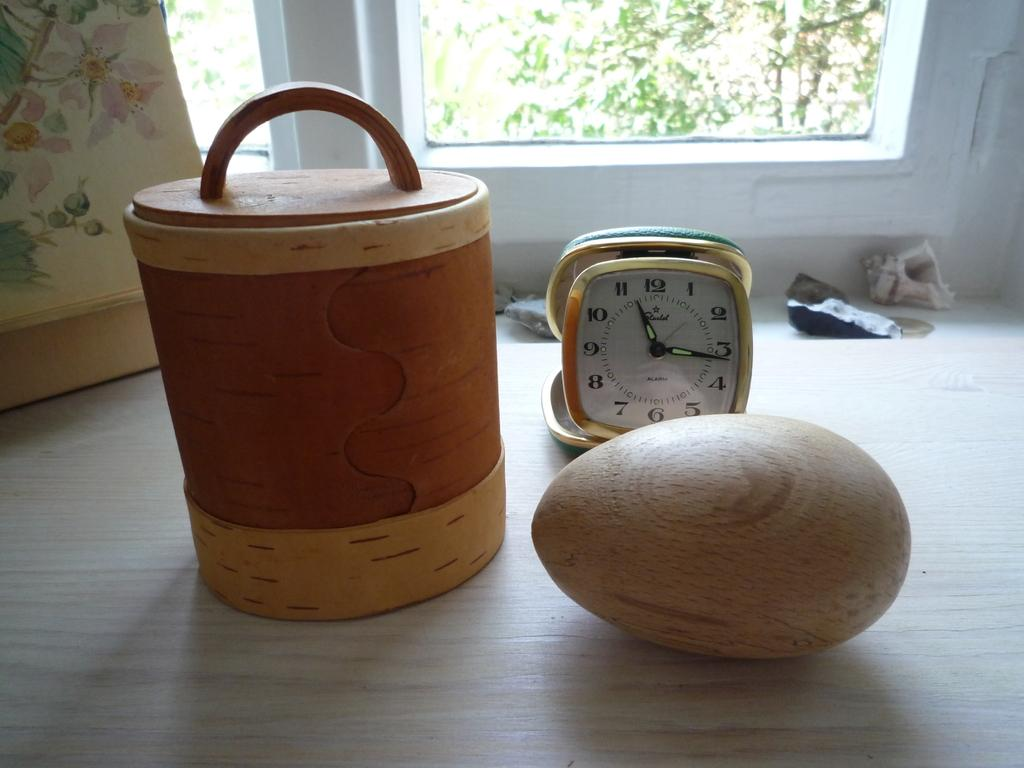<image>
Create a compact narrative representing the image presented. A wooden egg in front of a travel alarm clock that says alarm on the face. 